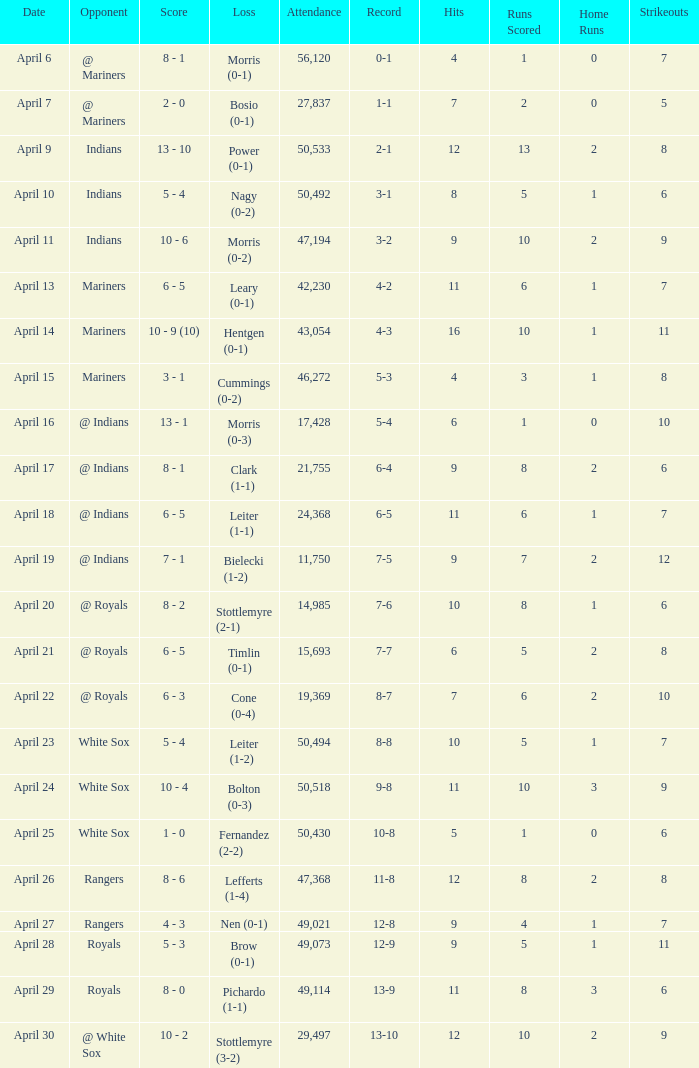I'm looking to parse the entire table for insights. Could you assist me with that? {'header': ['Date', 'Opponent', 'Score', 'Loss', 'Attendance', 'Record', 'Hits', 'Runs Scored', 'Home Runs', 'Strikeouts'], 'rows': [['April 6', '@ Mariners', '8 - 1', 'Morris (0-1)', '56,120', '0-1', '4', '1', '0', '7'], ['April 7', '@ Mariners', '2 - 0', 'Bosio (0-1)', '27,837', '1-1', '7', '2', '0', '5'], ['April 9', 'Indians', '13 - 10', 'Power (0-1)', '50,533', '2-1', '12', '13', '2', '8'], ['April 10', 'Indians', '5 - 4', 'Nagy (0-2)', '50,492', '3-1', '8', '5', '1', '6'], ['April 11', 'Indians', '10 - 6', 'Morris (0-2)', '47,194', '3-2', '9', '10', '2', '9'], ['April 13', 'Mariners', '6 - 5', 'Leary (0-1)', '42,230', '4-2', '11', '6', '1', '7'], ['April 14', 'Mariners', '10 - 9 (10)', 'Hentgen (0-1)', '43,054', '4-3', '16', '10', '1', '11'], ['April 15', 'Mariners', '3 - 1', 'Cummings (0-2)', '46,272', '5-3', '4', '3', '1', '8'], ['April 16', '@ Indians', '13 - 1', 'Morris (0-3)', '17,428', '5-4', '6', '1', '0', '10'], ['April 17', '@ Indians', '8 - 1', 'Clark (1-1)', '21,755', '6-4', '9', '8', '2', '6'], ['April 18', '@ Indians', '6 - 5', 'Leiter (1-1)', '24,368', '6-5', '11', '6', '1', '7'], ['April 19', '@ Indians', '7 - 1', 'Bielecki (1-2)', '11,750', '7-5', '9', '7', '2', '12'], ['April 20', '@ Royals', '8 - 2', 'Stottlemyre (2-1)', '14,985', '7-6', '10', '8', '1', '6'], ['April 21', '@ Royals', '6 - 5', 'Timlin (0-1)', '15,693', '7-7', '6', '5', '2', '8'], ['April 22', '@ Royals', '6 - 3', 'Cone (0-4)', '19,369', '8-7', '7', '6', '2', '10'], ['April 23', 'White Sox', '5 - 4', 'Leiter (1-2)', '50,494', '8-8', '10', '5', '1', '7'], ['April 24', 'White Sox', '10 - 4', 'Bolton (0-3)', '50,518', '9-8', '11', '10', '3', '9'], ['April 25', 'White Sox', '1 - 0', 'Fernandez (2-2)', '50,430', '10-8', '5', '1', '0', '6'], ['April 26', 'Rangers', '8 - 6', 'Lefferts (1-4)', '47,368', '11-8', '12', '8', '2', '8'], ['April 27', 'Rangers', '4 - 3', 'Nen (0-1)', '49,021', '12-8', '9', '4', '1', '7'], ['April 28', 'Royals', '5 - 3', 'Brow (0-1)', '49,073', '12-9', '9', '5', '1', '11'], ['April 29', 'Royals', '8 - 0', 'Pichardo (1-1)', '49,114', '13-9', '11', '8', '3', '6'], ['April 30', '@ White Sox', '10 - 2', 'Stottlemyre (3-2)', '29,497', '13-10', '12', '10', '2', '9']]} What scored is recorded on April 24? 10 - 4. 